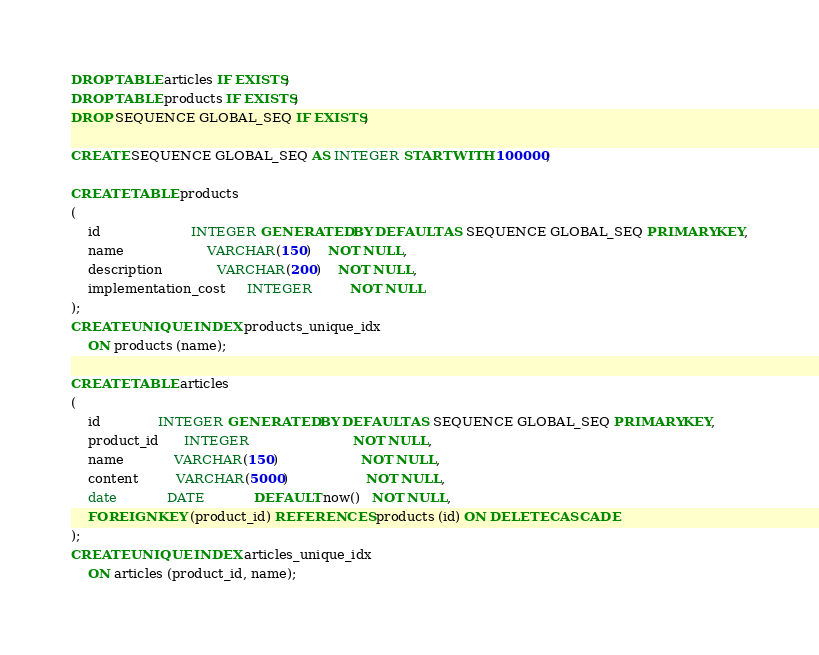<code> <loc_0><loc_0><loc_500><loc_500><_SQL_>DROP TABLE articles IF EXISTS;
DROP TABLE products IF EXISTS;
DROP SEQUENCE GLOBAL_SEQ IF EXISTS;

CREATE SEQUENCE GLOBAL_SEQ AS INTEGER START WITH 100000;

CREATE TABLE products
(
    id                      INTEGER GENERATED BY DEFAULT AS SEQUENCE GLOBAL_SEQ PRIMARY KEY,
    name                    VARCHAR(150)    NOT NULL,
    description             VARCHAR(200)    NOT NULL,
    implementation_cost     INTEGER         NOT NULL
);
CREATE UNIQUE INDEX products_unique_idx
    ON products (name);

CREATE TABLE articles
(
    id              INTEGER GENERATED BY DEFAULT AS SEQUENCE GLOBAL_SEQ PRIMARY KEY,
    product_id      INTEGER                         NOT NULL,
    name            VARCHAR(150)                    NOT NULL,
    content         VARCHAR(5000)                   NOT NULL,
    date            DATE            DEFAULT now()   NOT NULL,
    FOREIGN KEY (product_id) REFERENCES products (id) ON DELETE CASCADE
);
CREATE UNIQUE INDEX articles_unique_idx
    ON articles (product_id, name);

</code> 